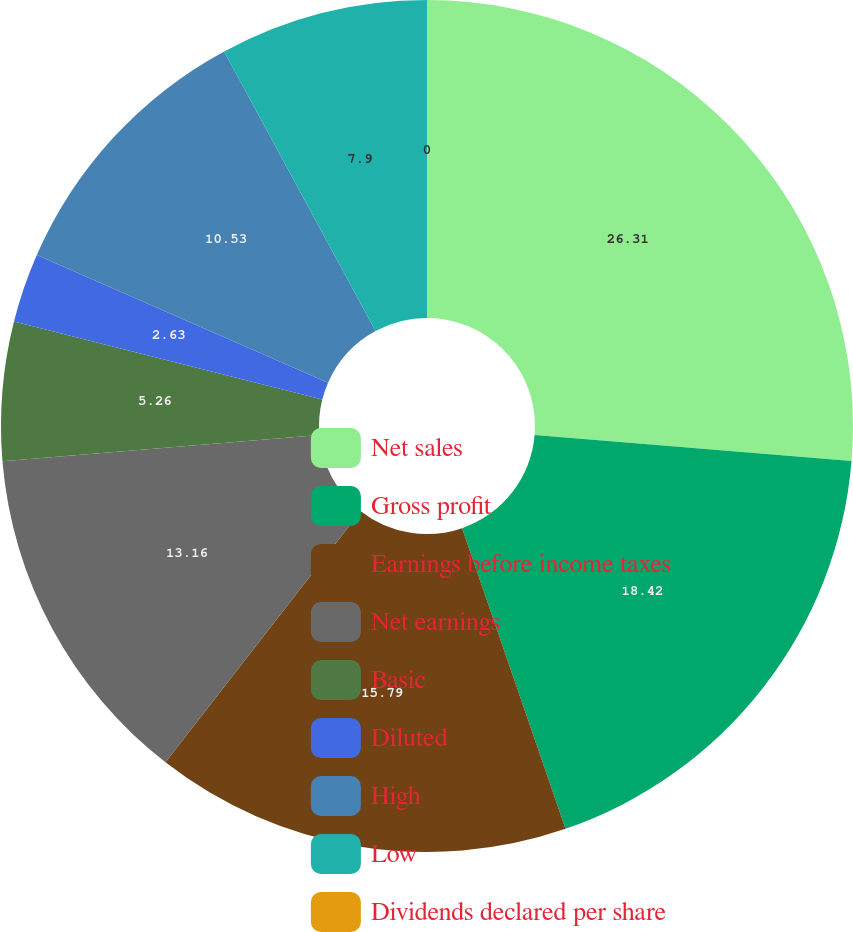Convert chart to OTSL. <chart><loc_0><loc_0><loc_500><loc_500><pie_chart><fcel>Net sales<fcel>Gross profit<fcel>Earnings before income taxes<fcel>Net earnings<fcel>Basic<fcel>Diluted<fcel>High<fcel>Low<fcel>Dividends declared per share<nl><fcel>26.31%<fcel>18.42%<fcel>15.79%<fcel>13.16%<fcel>5.26%<fcel>2.63%<fcel>10.53%<fcel>7.9%<fcel>0.0%<nl></chart> 